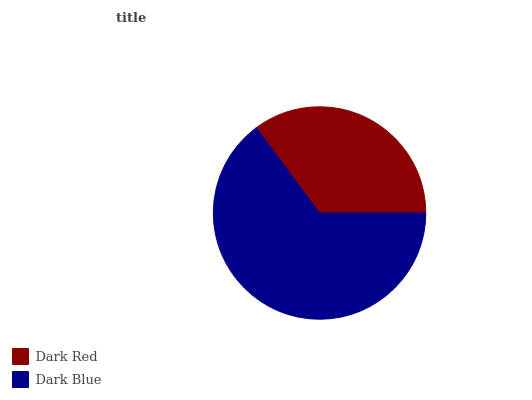Is Dark Red the minimum?
Answer yes or no. Yes. Is Dark Blue the maximum?
Answer yes or no. Yes. Is Dark Blue the minimum?
Answer yes or no. No. Is Dark Blue greater than Dark Red?
Answer yes or no. Yes. Is Dark Red less than Dark Blue?
Answer yes or no. Yes. Is Dark Red greater than Dark Blue?
Answer yes or no. No. Is Dark Blue less than Dark Red?
Answer yes or no. No. Is Dark Blue the high median?
Answer yes or no. Yes. Is Dark Red the low median?
Answer yes or no. Yes. Is Dark Red the high median?
Answer yes or no. No. Is Dark Blue the low median?
Answer yes or no. No. 